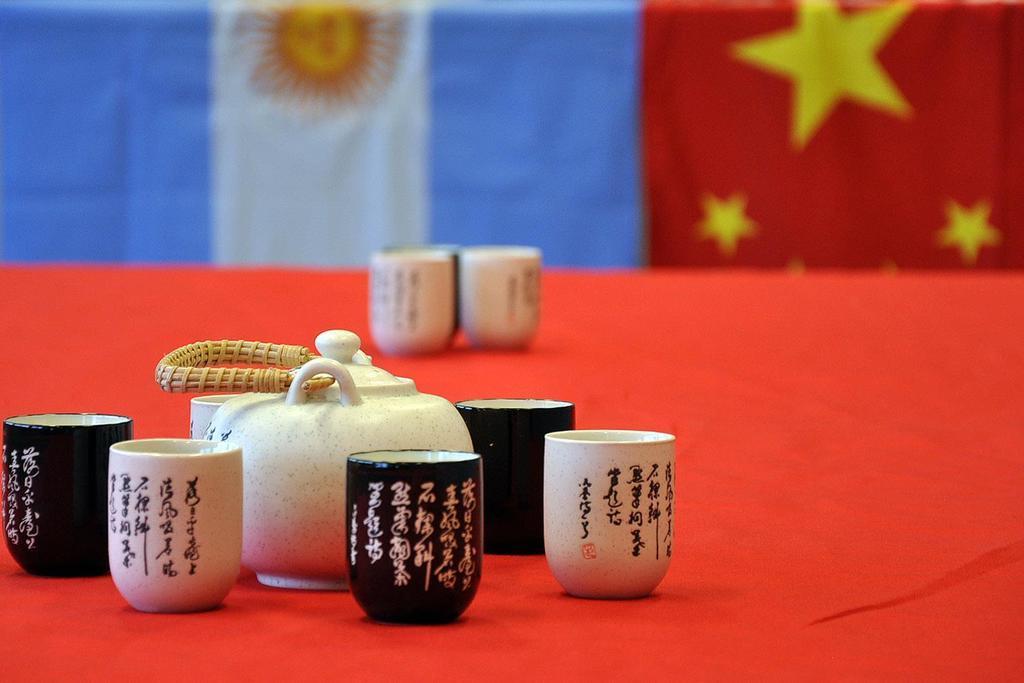Could you give a brief overview of what you see in this image? As we can see in the image there are flags, table and on table there are glasses. 